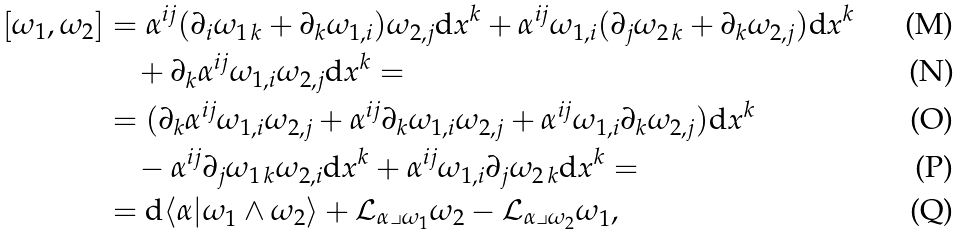Convert formula to latex. <formula><loc_0><loc_0><loc_500><loc_500>[ \omega _ { 1 } , \omega _ { 2 } ] & = \alpha ^ { i j } ( \partial _ { i } \omega _ { 1 \, k } + \partial _ { k } \omega _ { 1 , i } ) \omega _ { 2 , j } \mathrm d x ^ { k } + \alpha ^ { i j } \omega _ { 1 , i } ( \partial _ { j } \omega _ { 2 \, k } + \partial _ { k } \omega _ { 2 , j } ) \mathrm d x ^ { k } \\ & \quad + \partial _ { k } \alpha ^ { i j } \omega _ { 1 , i } \omega _ { 2 , j } \mathrm d x ^ { k } = \\ & = ( \partial _ { k } \alpha ^ { i j } \omega _ { 1 , i } \omega _ { 2 , j } + \alpha ^ { i j } \partial _ { k } \omega _ { 1 , i } \omega _ { 2 , j } + \alpha ^ { i j } \omega _ { 1 , i } \partial _ { k } \omega _ { 2 , j } ) \mathrm d x ^ { k } \\ & \quad - \alpha ^ { i j } \partial _ { j } \omega _ { 1 \, k } \omega _ { 2 , i } \mathrm d x ^ { k } + \alpha ^ { i j } \omega _ { 1 , i } \partial _ { j } \omega _ { 2 \, k } \mathrm d x ^ { k } = \\ & = \mathrm d \langle \alpha | \omega _ { 1 } \wedge \omega _ { 2 } \rangle + { \mathcal { L } } _ { \alpha \lrcorner \omega _ { 1 } } \omega _ { 2 } - { \mathcal { L } } _ { \alpha \lrcorner \omega _ { 2 } } \omega _ { 1 } ,</formula> 